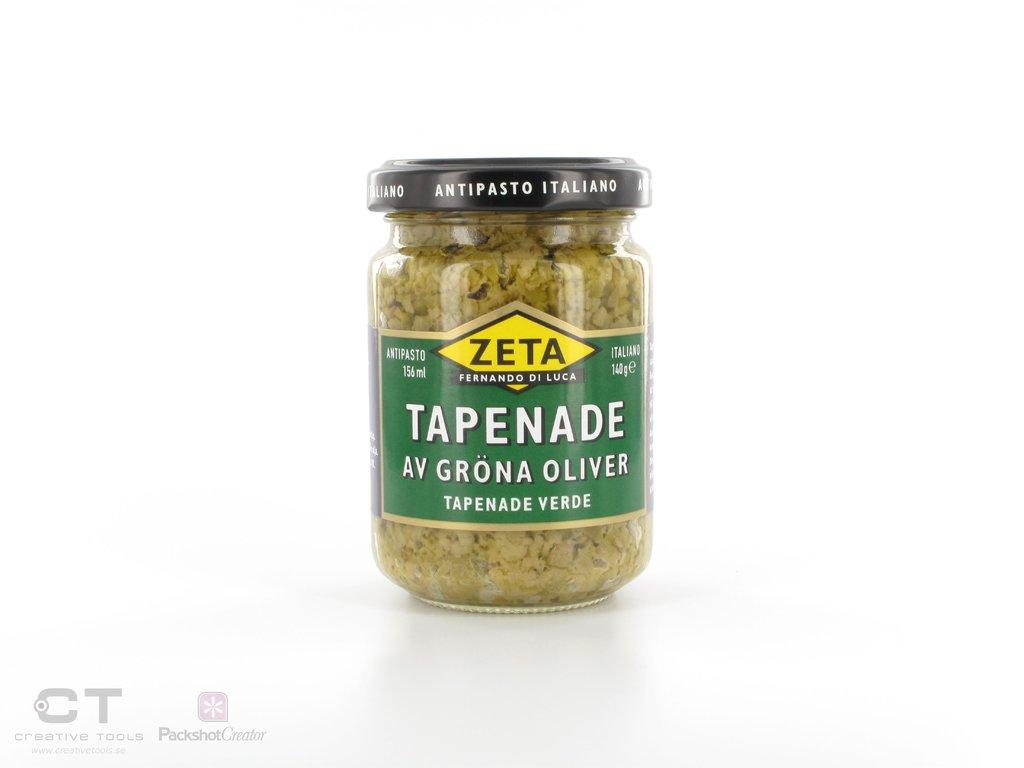What object is visible in the image that is typically used for holding liquids? There is a glass bottle in the image. What can be found inside the glass bottle? There is a food item inside the glass bottle. How many girls are present in the image? There is no girl present in the image; it only features a glass bottle with a food item inside. 